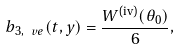Convert formula to latex. <formula><loc_0><loc_0><loc_500><loc_500>b _ { 3 , \ v e } ( t , y ) = \frac { W ^ { \text {(iv)} } ( \theta _ { 0 } ) } { 6 } ,</formula> 